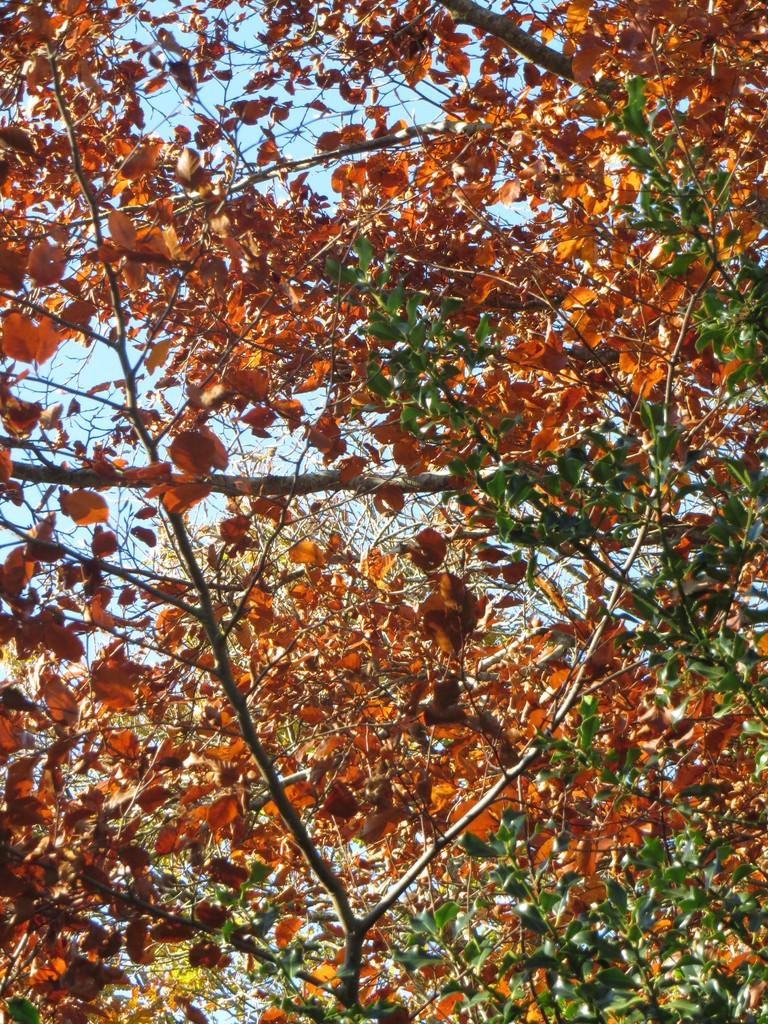What type of vegetation can be seen in the image? There are trees in the image. What part of the natural environment is visible in the image? The sky is visible in the image. What type of yam is being played by the father in the image? There is no father or yam present in the image; it only features trees and the sky. 